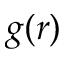Convert formula to latex. <formula><loc_0><loc_0><loc_500><loc_500>g ( r )</formula> 